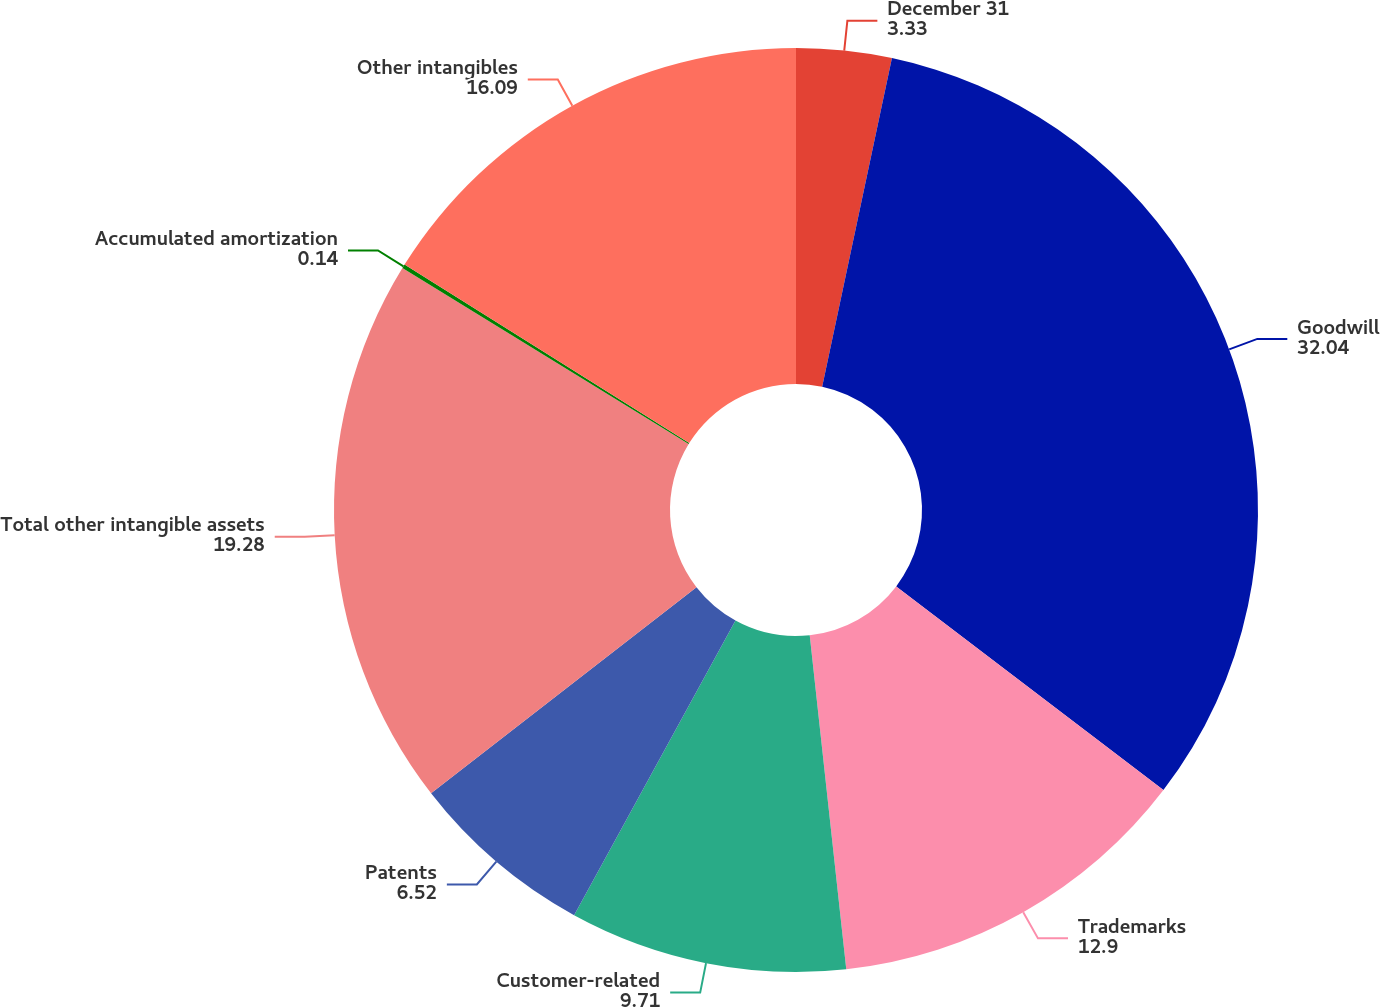<chart> <loc_0><loc_0><loc_500><loc_500><pie_chart><fcel>December 31<fcel>Goodwill<fcel>Trademarks<fcel>Customer-related<fcel>Patents<fcel>Total other intangible assets<fcel>Accumulated amortization<fcel>Other intangibles<nl><fcel>3.33%<fcel>32.04%<fcel>12.9%<fcel>9.71%<fcel>6.52%<fcel>19.28%<fcel>0.14%<fcel>16.09%<nl></chart> 